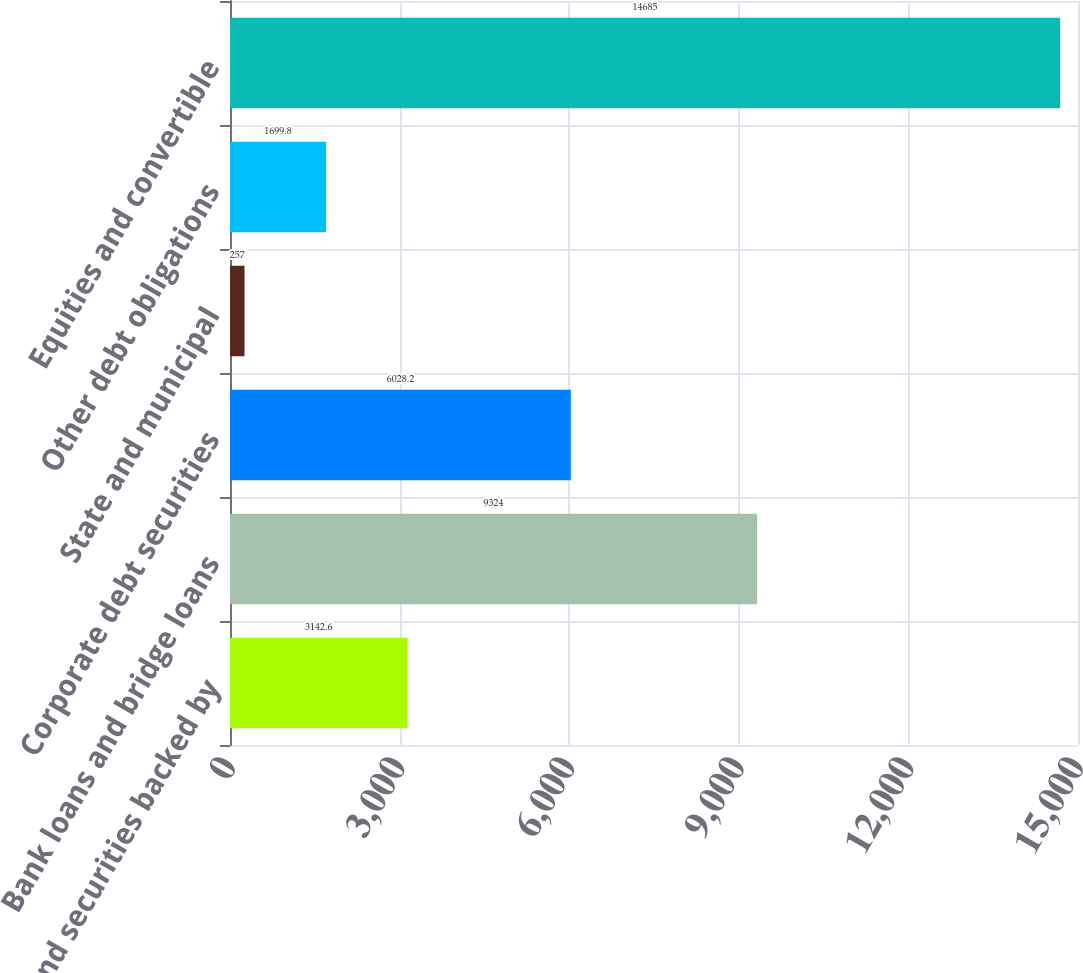<chart> <loc_0><loc_0><loc_500><loc_500><bar_chart><fcel>Loans and securities backed by<fcel>Bank loans and bridge loans<fcel>Corporate debt securities<fcel>State and municipal<fcel>Other debt obligations<fcel>Equities and convertible<nl><fcel>3142.6<fcel>9324<fcel>6028.2<fcel>257<fcel>1699.8<fcel>14685<nl></chart> 